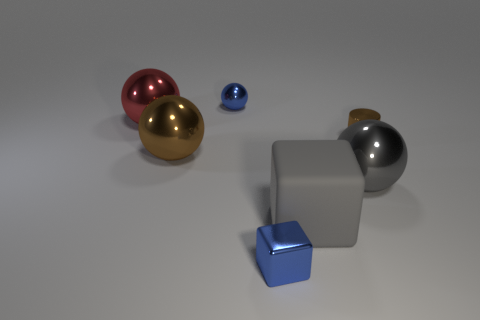What material is the other object that is the same color as the matte thing?
Your response must be concise. Metal. Is there a tiny cyan matte ball?
Your answer should be very brief. No. What is the size of the thing that is both on the right side of the big brown object and to the left of the small shiny block?
Your response must be concise. Small. The gray shiny thing is what shape?
Your response must be concise. Sphere. Is there a big gray metallic thing that is to the right of the brown thing that is on the left side of the gray matte block?
Offer a terse response. Yes. There is a gray sphere that is the same size as the red thing; what is its material?
Offer a terse response. Metal. Is there a metal cylinder of the same size as the gray cube?
Your answer should be compact. No. What is the blue thing that is in front of the brown ball made of?
Ensure brevity in your answer.  Metal. Does the ball on the left side of the brown metallic ball have the same material as the blue block?
Your answer should be very brief. Yes. There is a brown thing that is the same size as the shiny block; what shape is it?
Offer a terse response. Cylinder. 